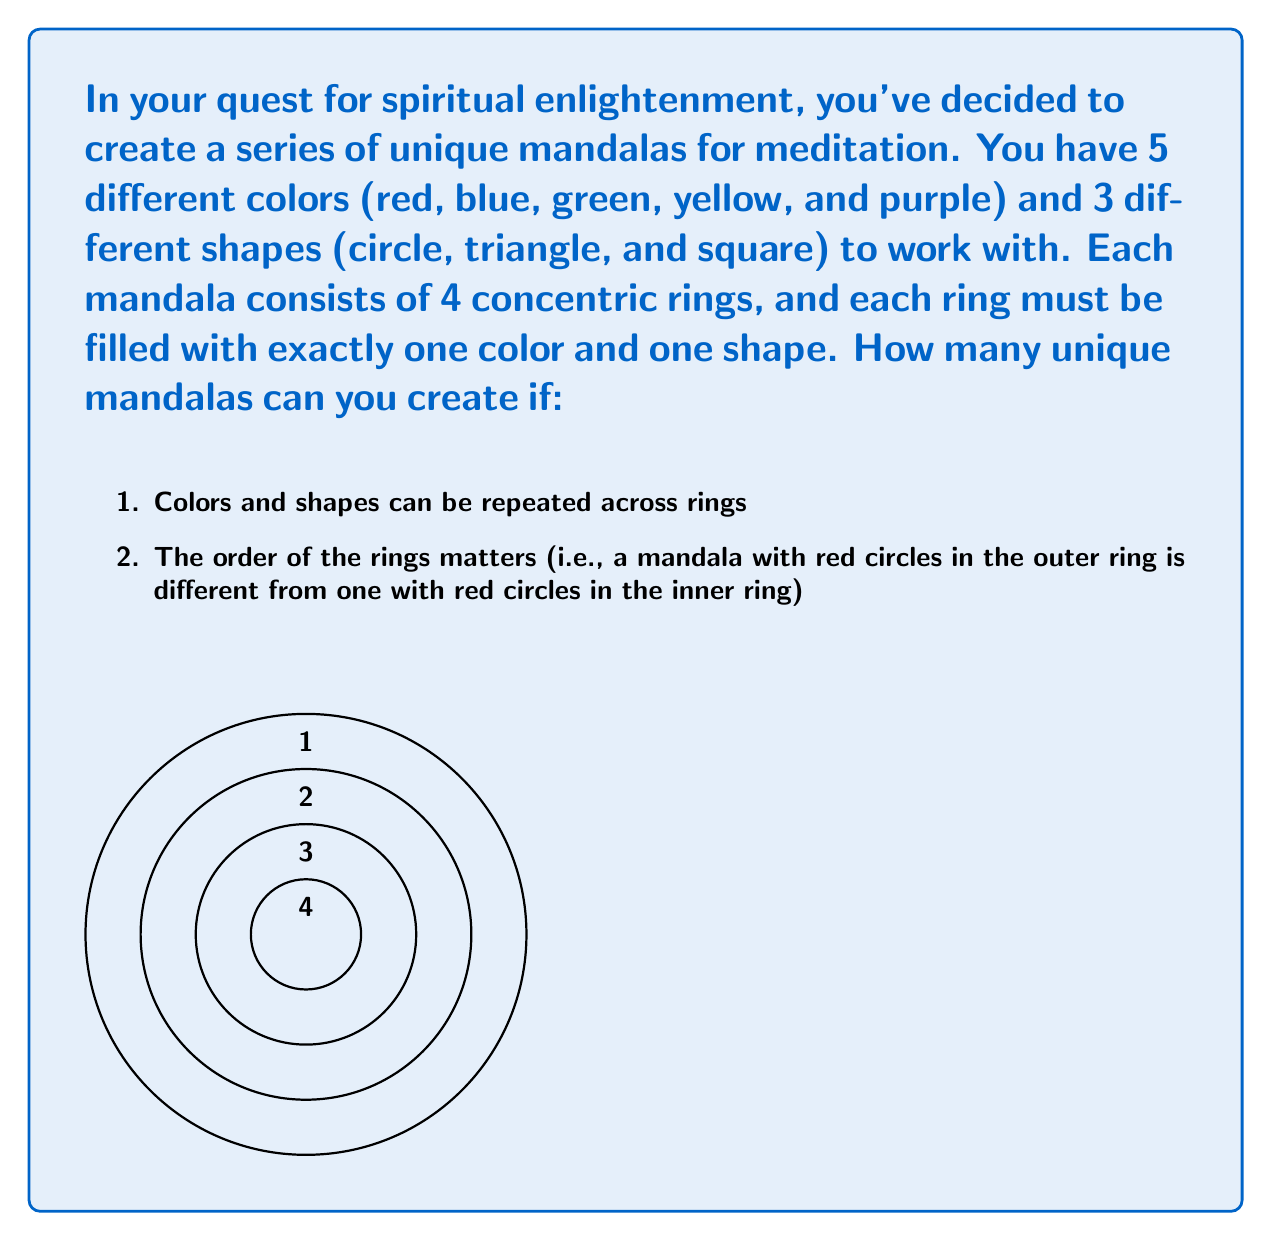Give your solution to this math problem. Let's approach this step-by-step:

1) For each ring, we need to choose both a color and a shape. These choices are independent of each other.

2) For each ring:
   - We have 5 choices for color
   - We have 3 choices for shape
   - Total choices for each ring = 5 × 3 = 15

3) We need to make this choice for each of the 4 rings, and the order matters. This is a case of the multiplication principle.

4) The total number of unique mandalas is therefore:

   $$(5 \times 3)^4 = 15^4$$

5) Let's calculate this:
   
   $$15^4 = 15 \times 15 \times 15 \times 15 = 50,625$$

Therefore, you can create 50,625 unique mandalas with the given set of colors and shapes.
Answer: 50,625 